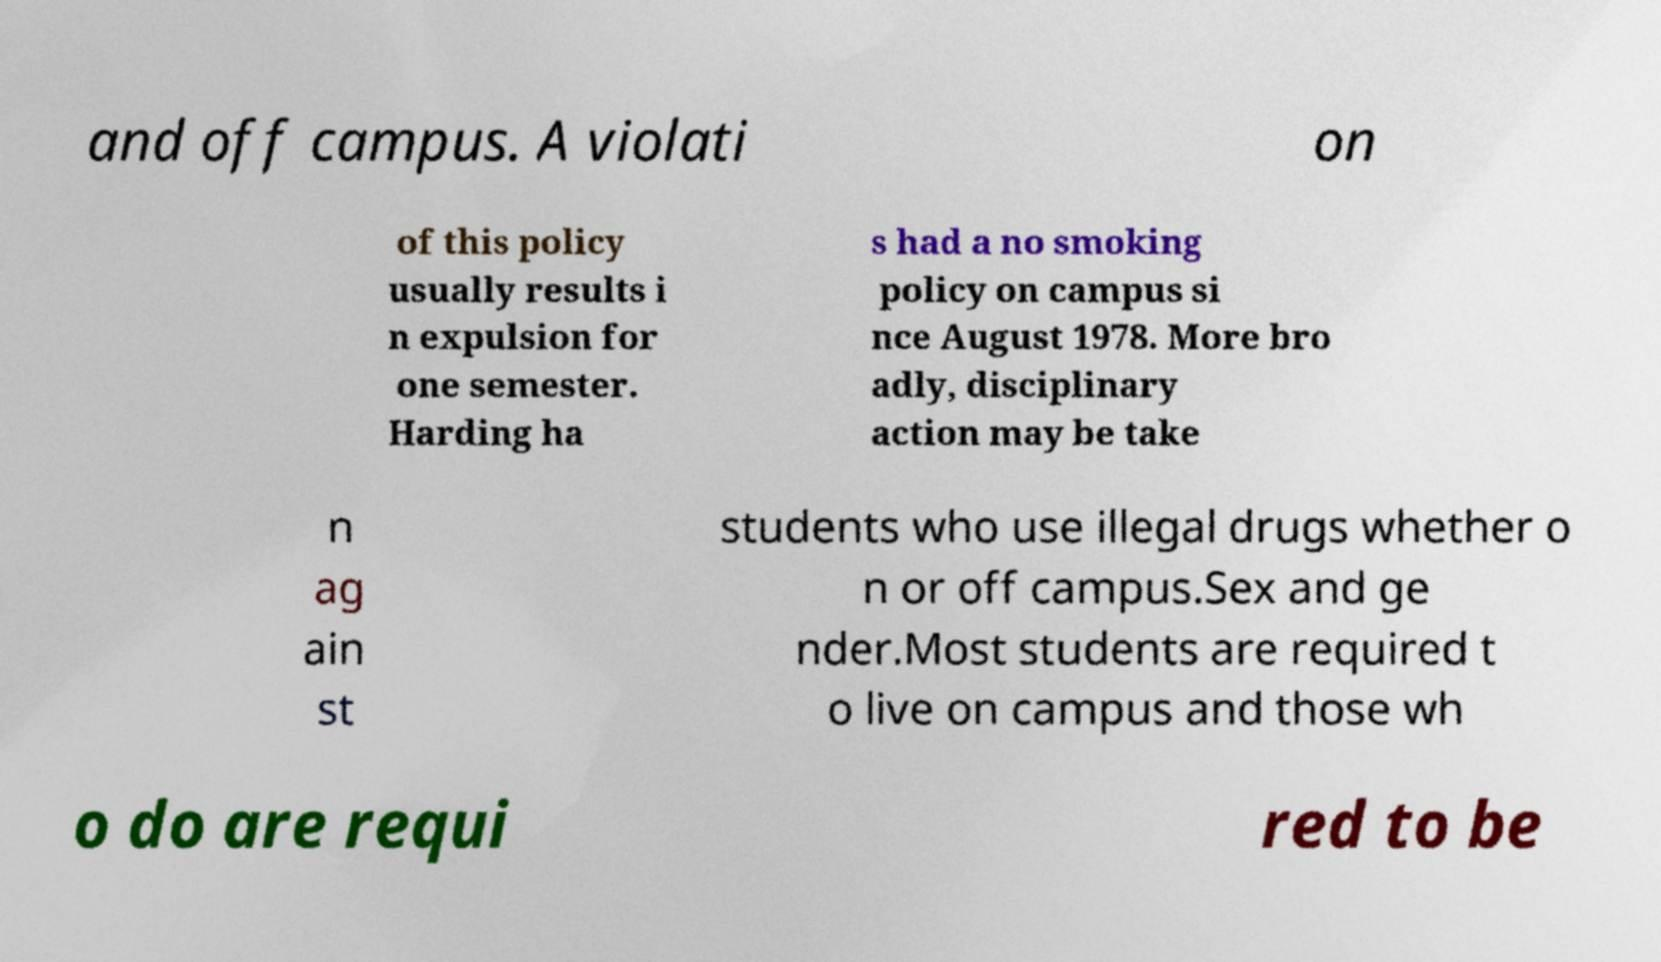What messages or text are displayed in this image? I need them in a readable, typed format. and off campus. A violati on of this policy usually results i n expulsion for one semester. Harding ha s had a no smoking policy on campus si nce August 1978. More bro adly, disciplinary action may be take n ag ain st students who use illegal drugs whether o n or off campus.Sex and ge nder.Most students are required t o live on campus and those wh o do are requi red to be 